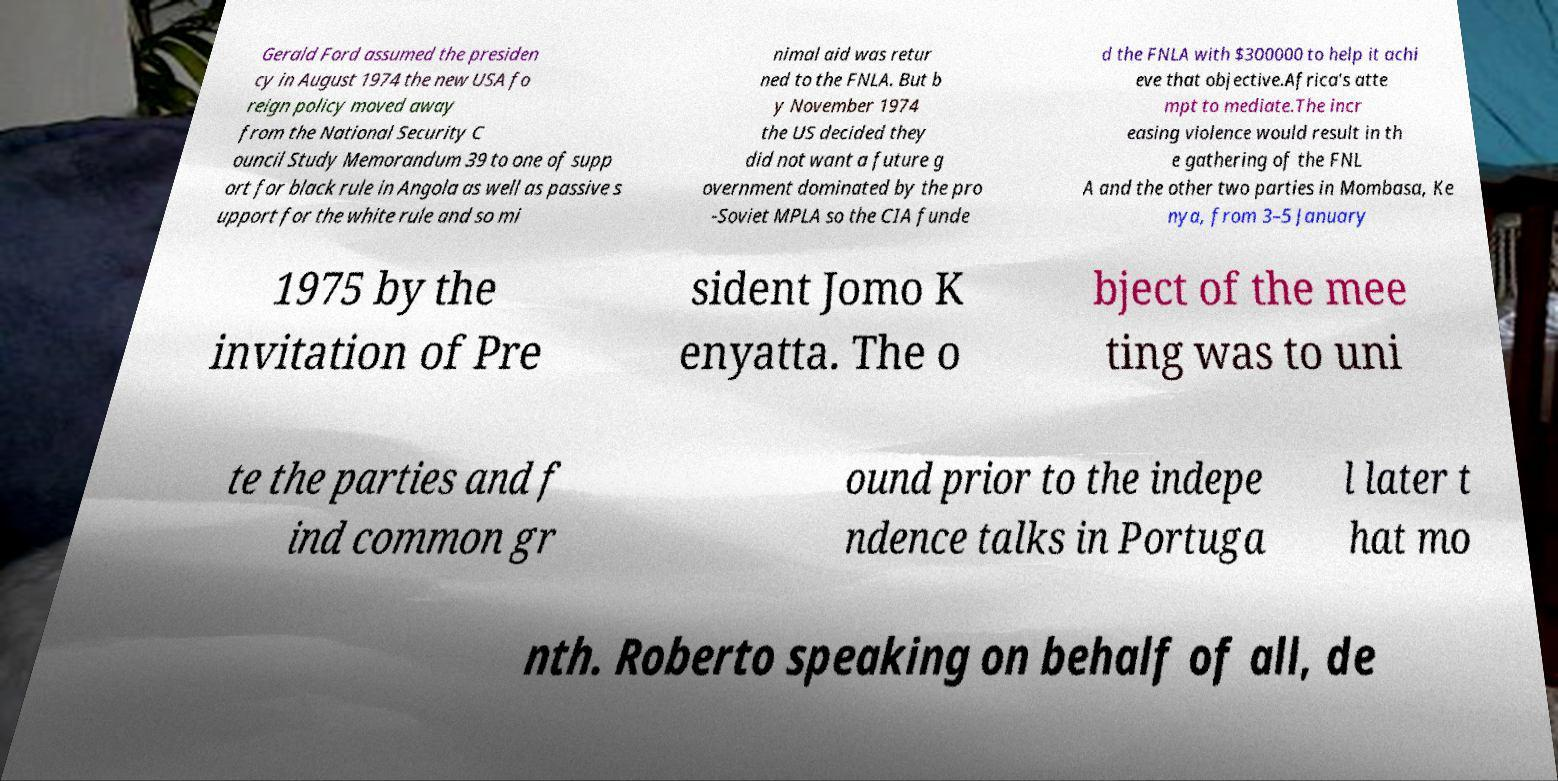For documentation purposes, I need the text within this image transcribed. Could you provide that? Gerald Ford assumed the presiden cy in August 1974 the new USA fo reign policy moved away from the National Security C ouncil Study Memorandum 39 to one of supp ort for black rule in Angola as well as passive s upport for the white rule and so mi nimal aid was retur ned to the FNLA. But b y November 1974 the US decided they did not want a future g overnment dominated by the pro -Soviet MPLA so the CIA funde d the FNLA with $300000 to help it achi eve that objective.Africa's atte mpt to mediate.The incr easing violence would result in th e gathering of the FNL A and the other two parties in Mombasa, Ke nya, from 3–5 January 1975 by the invitation of Pre sident Jomo K enyatta. The o bject of the mee ting was to uni te the parties and f ind common gr ound prior to the indepe ndence talks in Portuga l later t hat mo nth. Roberto speaking on behalf of all, de 